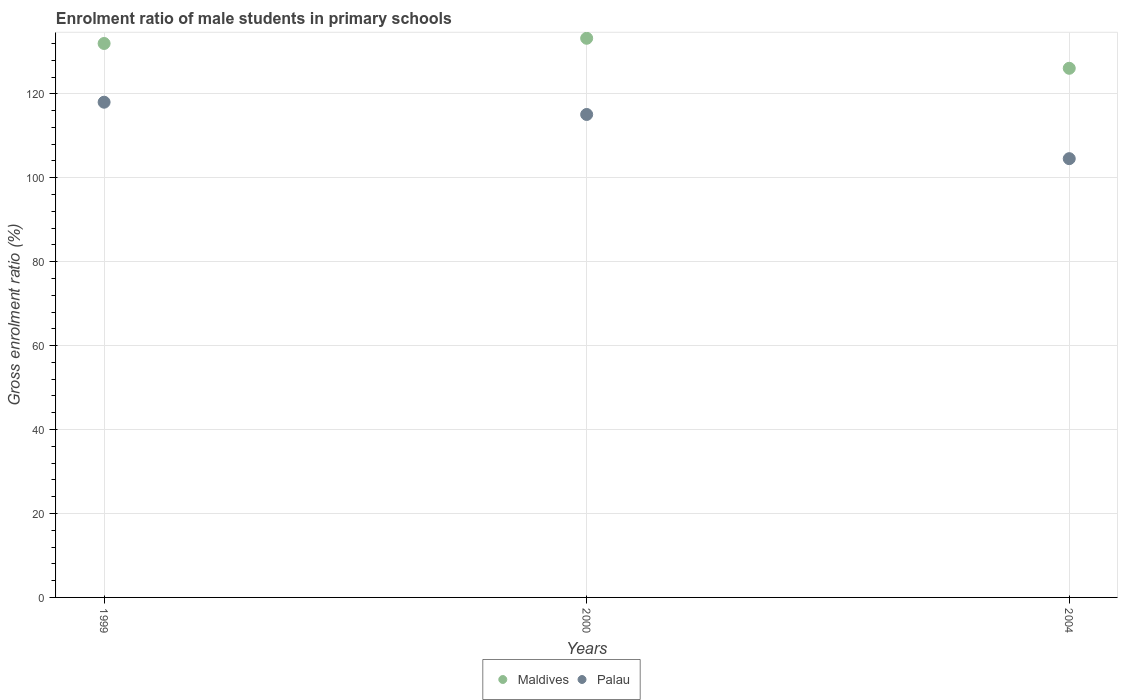Is the number of dotlines equal to the number of legend labels?
Your response must be concise. Yes. What is the enrolment ratio of male students in primary schools in Maldives in 1999?
Keep it short and to the point. 132. Across all years, what is the maximum enrolment ratio of male students in primary schools in Maldives?
Provide a short and direct response. 133.24. Across all years, what is the minimum enrolment ratio of male students in primary schools in Maldives?
Provide a succinct answer. 126.08. What is the total enrolment ratio of male students in primary schools in Maldives in the graph?
Your answer should be compact. 391.32. What is the difference between the enrolment ratio of male students in primary schools in Maldives in 2000 and that in 2004?
Make the answer very short. 7.15. What is the difference between the enrolment ratio of male students in primary schools in Palau in 2004 and the enrolment ratio of male students in primary schools in Maldives in 2000?
Ensure brevity in your answer.  -28.69. What is the average enrolment ratio of male students in primary schools in Maldives per year?
Provide a short and direct response. 130.44. In the year 2004, what is the difference between the enrolment ratio of male students in primary schools in Maldives and enrolment ratio of male students in primary schools in Palau?
Offer a very short reply. 21.53. What is the ratio of the enrolment ratio of male students in primary schools in Palau in 1999 to that in 2000?
Give a very brief answer. 1.03. What is the difference between the highest and the second highest enrolment ratio of male students in primary schools in Maldives?
Ensure brevity in your answer.  1.24. What is the difference between the highest and the lowest enrolment ratio of male students in primary schools in Maldives?
Provide a succinct answer. 7.15. Is the enrolment ratio of male students in primary schools in Palau strictly less than the enrolment ratio of male students in primary schools in Maldives over the years?
Your response must be concise. Yes. How many years are there in the graph?
Keep it short and to the point. 3. What is the difference between two consecutive major ticks on the Y-axis?
Offer a very short reply. 20. Are the values on the major ticks of Y-axis written in scientific E-notation?
Ensure brevity in your answer.  No. How are the legend labels stacked?
Provide a short and direct response. Horizontal. What is the title of the graph?
Offer a terse response. Enrolment ratio of male students in primary schools. Does "Malawi" appear as one of the legend labels in the graph?
Your response must be concise. No. What is the label or title of the X-axis?
Offer a very short reply. Years. What is the Gross enrolment ratio (%) of Maldives in 1999?
Provide a short and direct response. 132. What is the Gross enrolment ratio (%) of Palau in 1999?
Your answer should be very brief. 118. What is the Gross enrolment ratio (%) in Maldives in 2000?
Your answer should be compact. 133.24. What is the Gross enrolment ratio (%) of Palau in 2000?
Keep it short and to the point. 115.08. What is the Gross enrolment ratio (%) in Maldives in 2004?
Ensure brevity in your answer.  126.08. What is the Gross enrolment ratio (%) in Palau in 2004?
Provide a succinct answer. 104.55. Across all years, what is the maximum Gross enrolment ratio (%) of Maldives?
Ensure brevity in your answer.  133.24. Across all years, what is the maximum Gross enrolment ratio (%) of Palau?
Keep it short and to the point. 118. Across all years, what is the minimum Gross enrolment ratio (%) of Maldives?
Your answer should be compact. 126.08. Across all years, what is the minimum Gross enrolment ratio (%) of Palau?
Your answer should be compact. 104.55. What is the total Gross enrolment ratio (%) of Maldives in the graph?
Your answer should be very brief. 391.32. What is the total Gross enrolment ratio (%) of Palau in the graph?
Your answer should be compact. 337.63. What is the difference between the Gross enrolment ratio (%) in Maldives in 1999 and that in 2000?
Your answer should be compact. -1.24. What is the difference between the Gross enrolment ratio (%) in Palau in 1999 and that in 2000?
Ensure brevity in your answer.  2.92. What is the difference between the Gross enrolment ratio (%) of Maldives in 1999 and that in 2004?
Make the answer very short. 5.91. What is the difference between the Gross enrolment ratio (%) of Palau in 1999 and that in 2004?
Offer a very short reply. 13.45. What is the difference between the Gross enrolment ratio (%) of Maldives in 2000 and that in 2004?
Offer a very short reply. 7.15. What is the difference between the Gross enrolment ratio (%) in Palau in 2000 and that in 2004?
Your response must be concise. 10.53. What is the difference between the Gross enrolment ratio (%) of Maldives in 1999 and the Gross enrolment ratio (%) of Palau in 2000?
Your answer should be very brief. 16.92. What is the difference between the Gross enrolment ratio (%) of Maldives in 1999 and the Gross enrolment ratio (%) of Palau in 2004?
Your answer should be very brief. 27.44. What is the difference between the Gross enrolment ratio (%) of Maldives in 2000 and the Gross enrolment ratio (%) of Palau in 2004?
Give a very brief answer. 28.69. What is the average Gross enrolment ratio (%) in Maldives per year?
Make the answer very short. 130.44. What is the average Gross enrolment ratio (%) in Palau per year?
Your response must be concise. 112.54. In the year 1999, what is the difference between the Gross enrolment ratio (%) of Maldives and Gross enrolment ratio (%) of Palau?
Provide a succinct answer. 13.99. In the year 2000, what is the difference between the Gross enrolment ratio (%) of Maldives and Gross enrolment ratio (%) of Palau?
Offer a very short reply. 18.16. In the year 2004, what is the difference between the Gross enrolment ratio (%) of Maldives and Gross enrolment ratio (%) of Palau?
Provide a short and direct response. 21.53. What is the ratio of the Gross enrolment ratio (%) of Maldives in 1999 to that in 2000?
Your answer should be compact. 0.99. What is the ratio of the Gross enrolment ratio (%) in Palau in 1999 to that in 2000?
Your response must be concise. 1.03. What is the ratio of the Gross enrolment ratio (%) in Maldives in 1999 to that in 2004?
Provide a succinct answer. 1.05. What is the ratio of the Gross enrolment ratio (%) of Palau in 1999 to that in 2004?
Give a very brief answer. 1.13. What is the ratio of the Gross enrolment ratio (%) of Maldives in 2000 to that in 2004?
Provide a succinct answer. 1.06. What is the ratio of the Gross enrolment ratio (%) of Palau in 2000 to that in 2004?
Keep it short and to the point. 1.1. What is the difference between the highest and the second highest Gross enrolment ratio (%) in Maldives?
Offer a very short reply. 1.24. What is the difference between the highest and the second highest Gross enrolment ratio (%) of Palau?
Give a very brief answer. 2.92. What is the difference between the highest and the lowest Gross enrolment ratio (%) in Maldives?
Provide a short and direct response. 7.15. What is the difference between the highest and the lowest Gross enrolment ratio (%) of Palau?
Offer a very short reply. 13.45. 